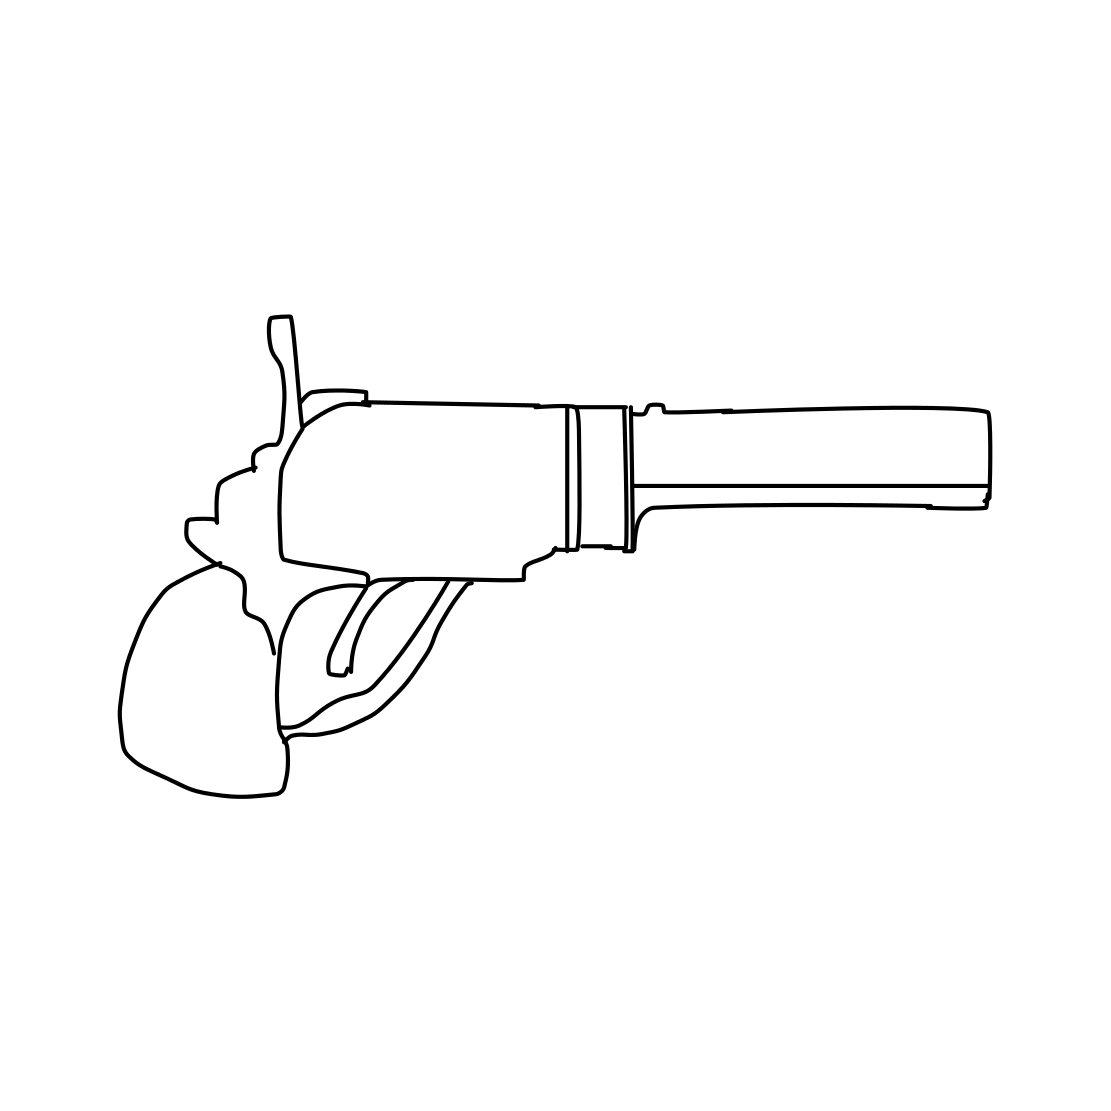What type of revolver is depicted here? Based on the outline, it appears to be a basic representation of a standard double-action revolver, characterized by its solid frame and swing-out cylinder, commonly found in various forms of media. 